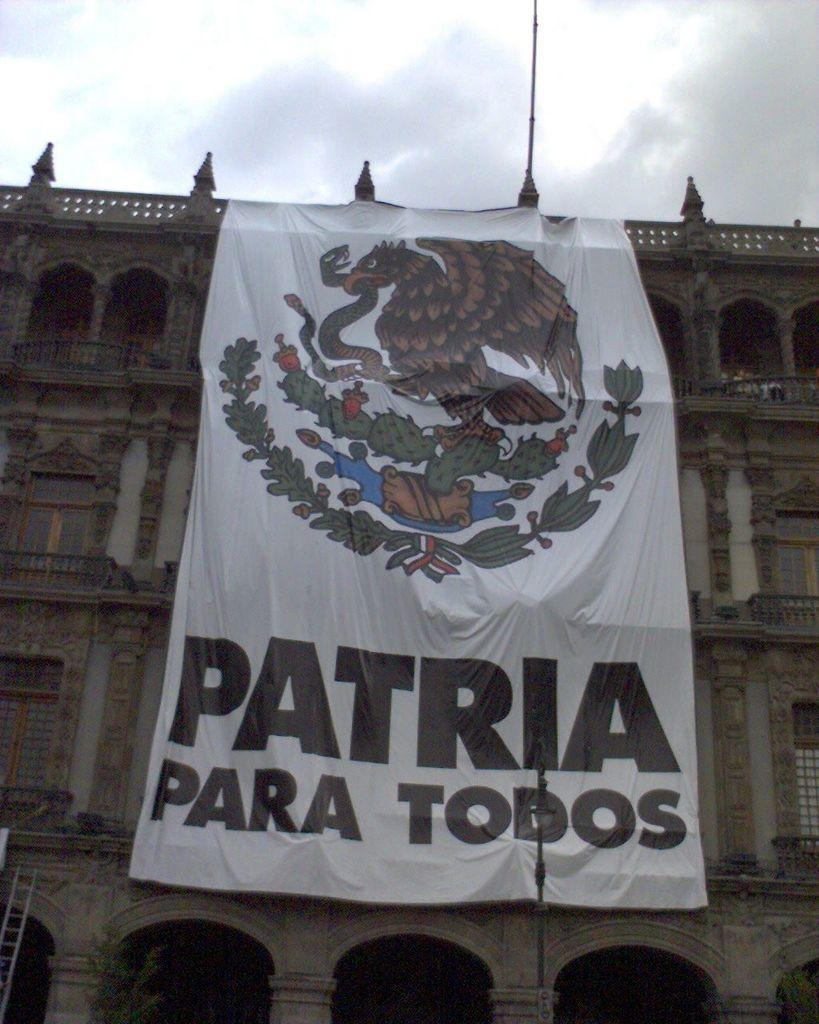What type of structure is visible in the image? There is a building in the image. What is hanging from the building in the image? There is a banner with text and pictures in the image. What tool or equipment is present in the image? There is a ladder in the image. What can be seen in the sky at the top of the image? There are clouds in the sky at the top of the image. Where is the honey stored in the image? There is no honey present in the image. What type of things can be seen on the stove in the image? There is no stove present in the image. 